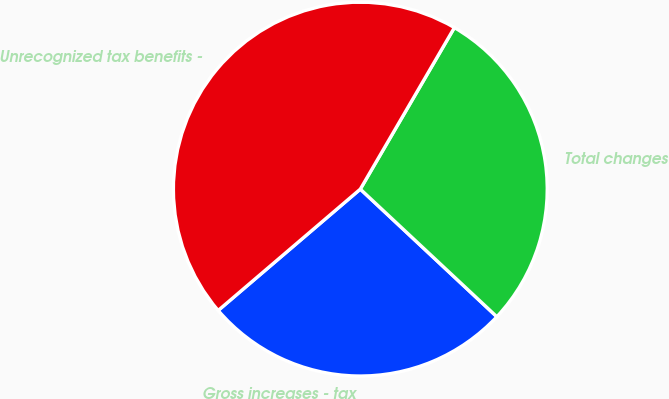Convert chart to OTSL. <chart><loc_0><loc_0><loc_500><loc_500><pie_chart><fcel>Gross increases - tax<fcel>Total changes<fcel>Unrecognized tax benefits -<nl><fcel>26.79%<fcel>28.57%<fcel>44.64%<nl></chart> 